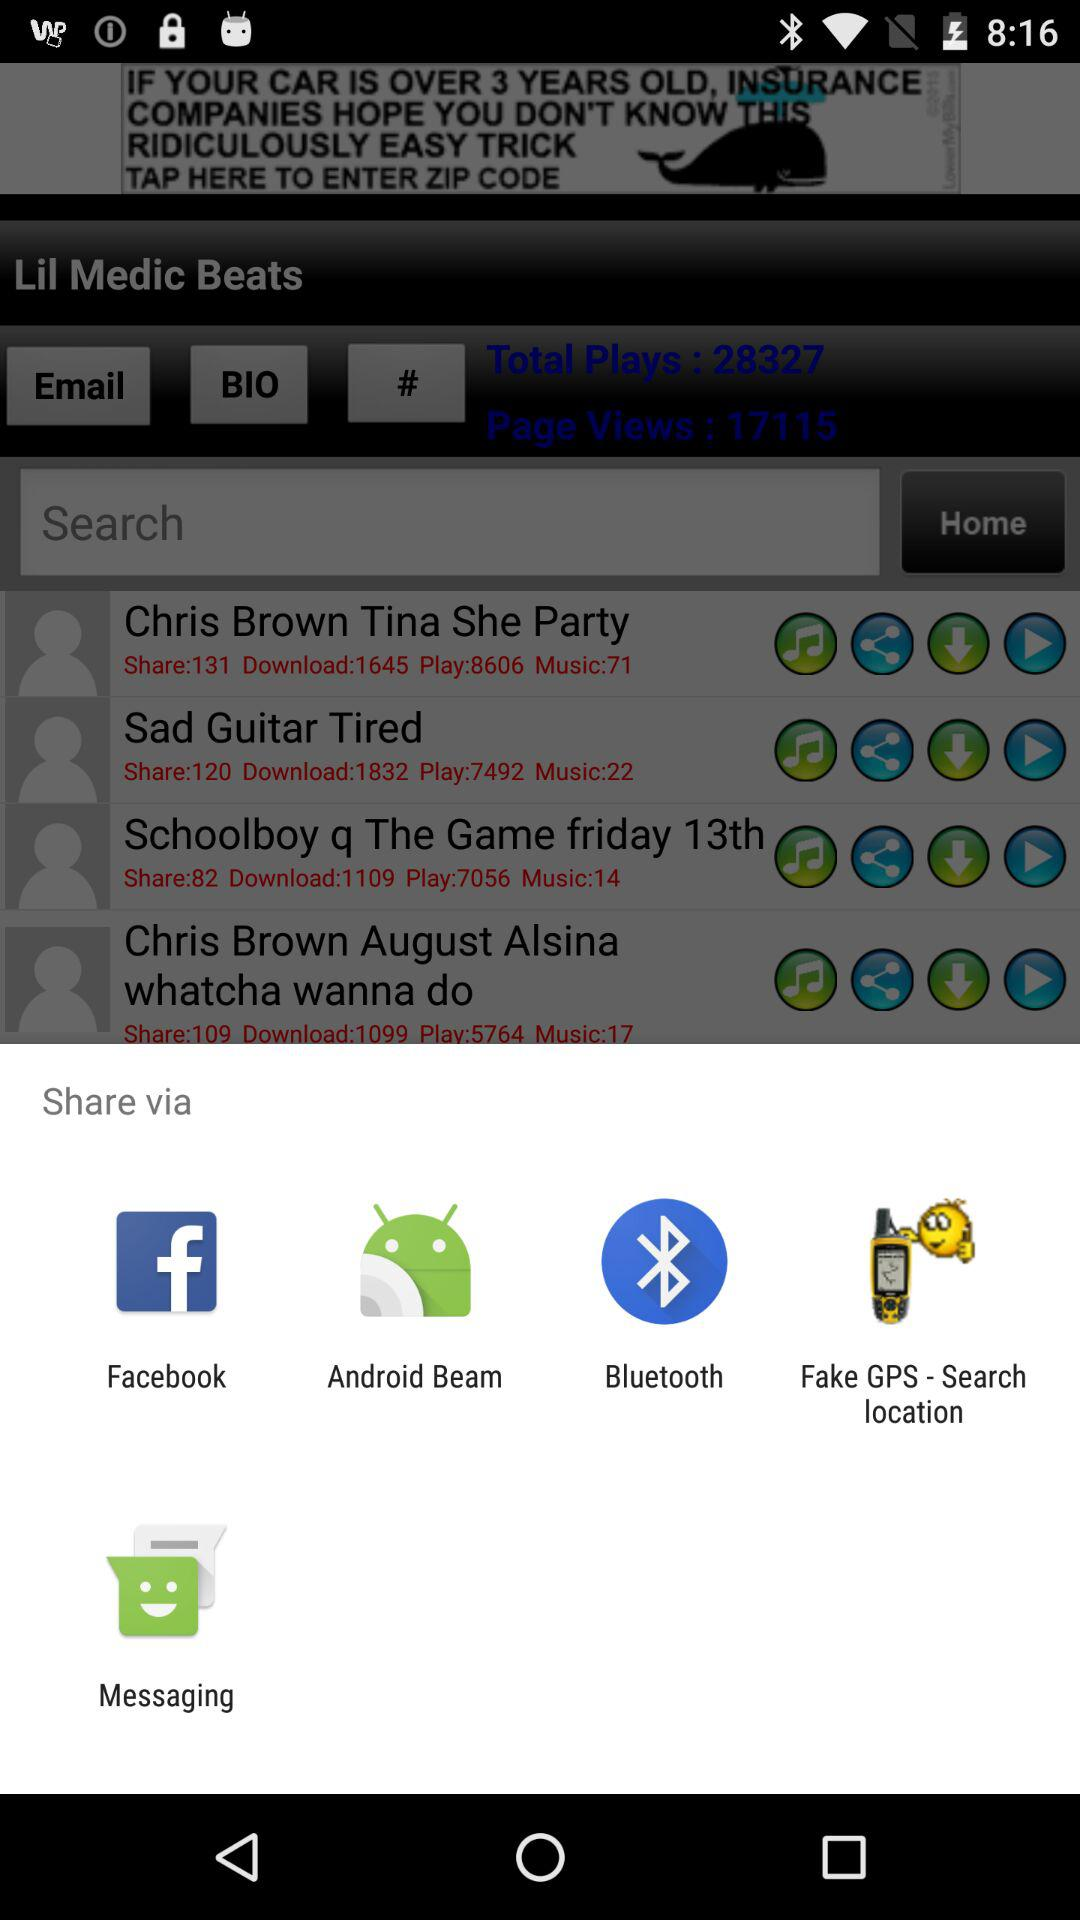How many plays does Chris Brown's 'Tina She Party' have?
Answer the question using a single word or phrase. 8606 